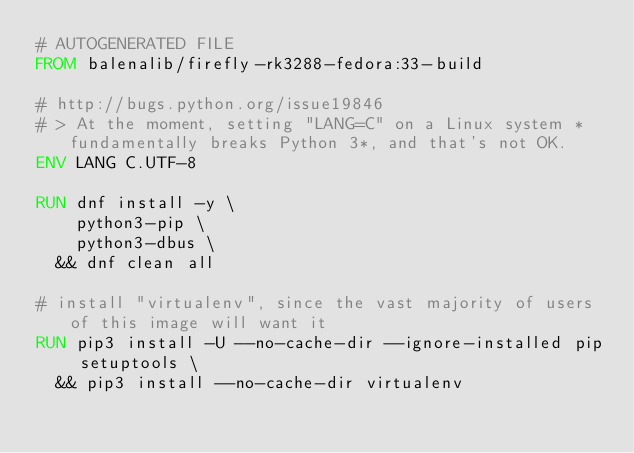<code> <loc_0><loc_0><loc_500><loc_500><_Dockerfile_># AUTOGENERATED FILE
FROM balenalib/firefly-rk3288-fedora:33-build

# http://bugs.python.org/issue19846
# > At the moment, setting "LANG=C" on a Linux system *fundamentally breaks Python 3*, and that's not OK.
ENV LANG C.UTF-8

RUN dnf install -y \
		python3-pip \
		python3-dbus \
	&& dnf clean all

# install "virtualenv", since the vast majority of users of this image will want it
RUN pip3 install -U --no-cache-dir --ignore-installed pip setuptools \
	&& pip3 install --no-cache-dir virtualenv
</code> 